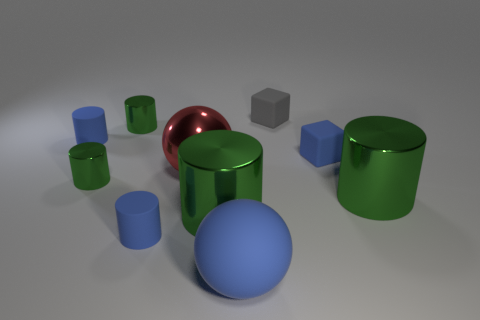What number of other large red things have the same shape as the large rubber thing?
Your answer should be very brief. 1. Does the gray object have the same material as the green thing that is behind the red metal ball?
Offer a terse response. No. The gray thing that is made of the same material as the large blue sphere is what size?
Offer a terse response. Small. What size is the blue rubber sphere in front of the small blue block?
Offer a very short reply. Large. What number of metallic things have the same size as the blue matte ball?
Your answer should be compact. 3. The rubber block that is the same color as the large matte ball is what size?
Provide a short and direct response. Small. Are there any small rubber objects that have the same color as the big rubber thing?
Provide a succinct answer. Yes. What is the color of the matte thing that is the same size as the red metal ball?
Offer a very short reply. Blue. Is the color of the big matte object the same as the small rubber thing that is in front of the large red ball?
Your answer should be very brief. Yes. What color is the large rubber thing?
Provide a short and direct response. Blue. 